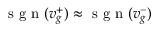<formula> <loc_0><loc_0><loc_500><loc_500>s g n ( v _ { g } ^ { + } ) \approx s g n ( v _ { g } ^ { - } )</formula> 